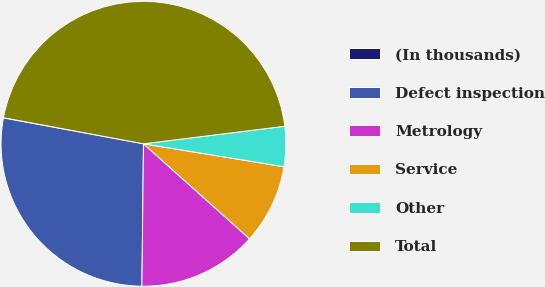<chart> <loc_0><loc_0><loc_500><loc_500><pie_chart><fcel>(In thousands)<fcel>Defect inspection<fcel>Metrology<fcel>Service<fcel>Other<fcel>Total<nl><fcel>0.03%<fcel>27.73%<fcel>13.55%<fcel>9.05%<fcel>4.54%<fcel>45.1%<nl></chart> 